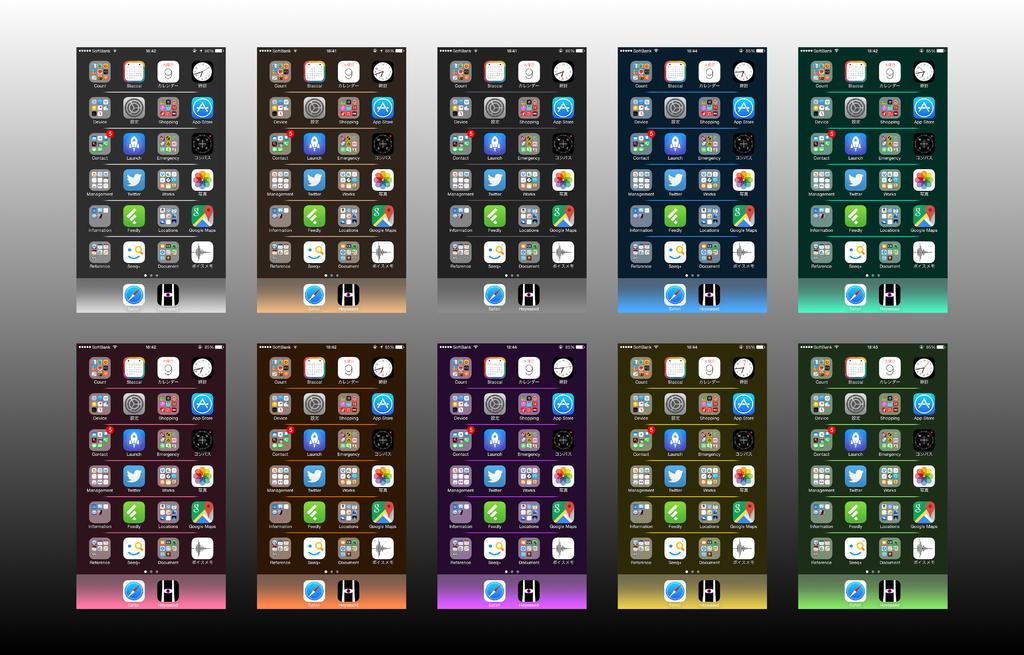How many mobile screens are visible in the image? There are ten mobile screens in the image. What can be found on each mobile screen? Each mobile screen has icons. What distinguishes the mobile screens from one another? The mobile screens have different colors. What type of knot is tied around the coat in the image? There is no coat or knot present in the image; it features ten mobile screens with icons and different colors. 